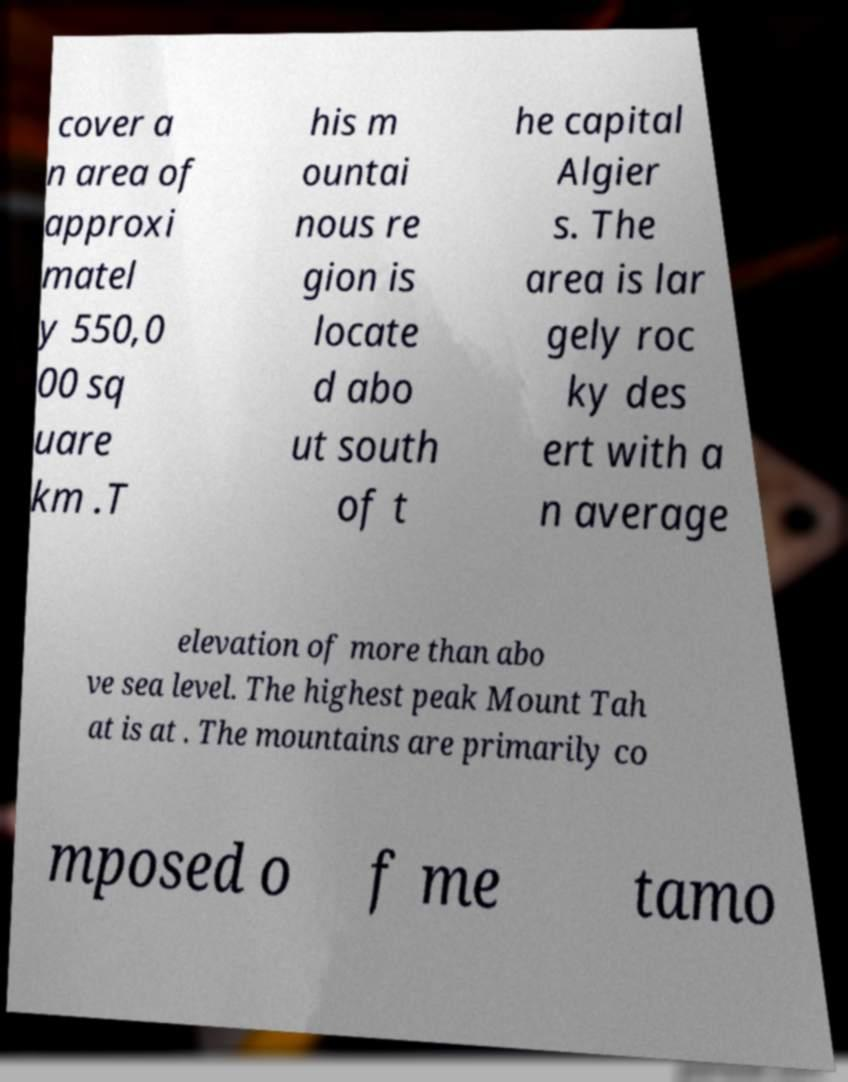Please read and relay the text visible in this image. What does it say? cover a n area of approxi matel y 550,0 00 sq uare km .T his m ountai nous re gion is locate d abo ut south of t he capital Algier s. The area is lar gely roc ky des ert with a n average elevation of more than abo ve sea level. The highest peak Mount Tah at is at . The mountains are primarily co mposed o f me tamo 